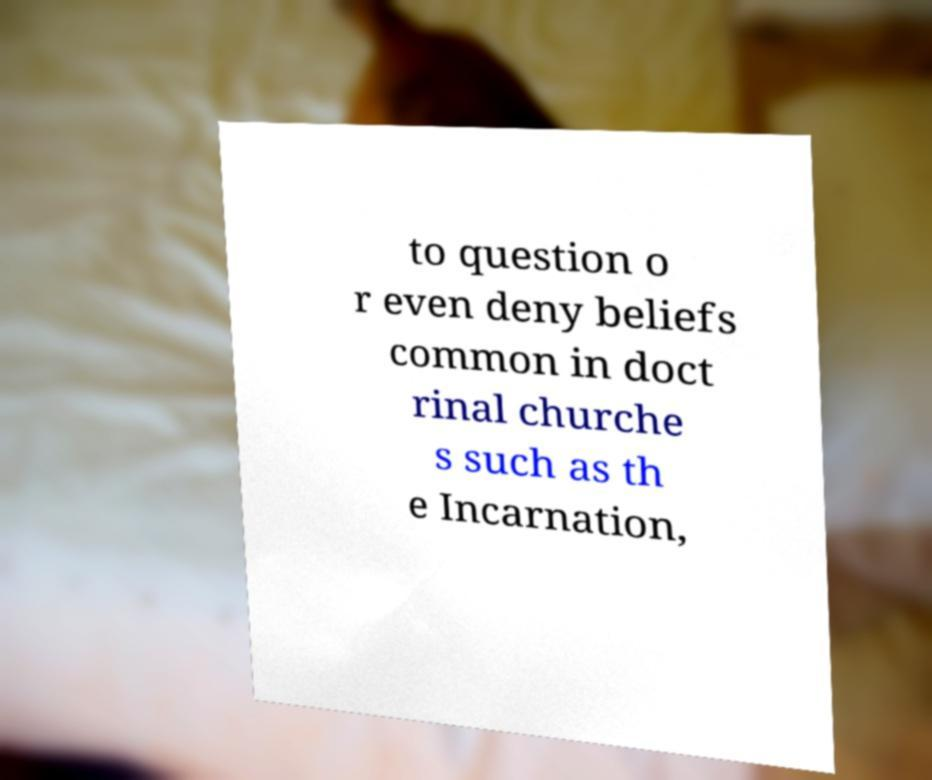I need the written content from this picture converted into text. Can you do that? to question o r even deny beliefs common in doct rinal churche s such as th e Incarnation, 